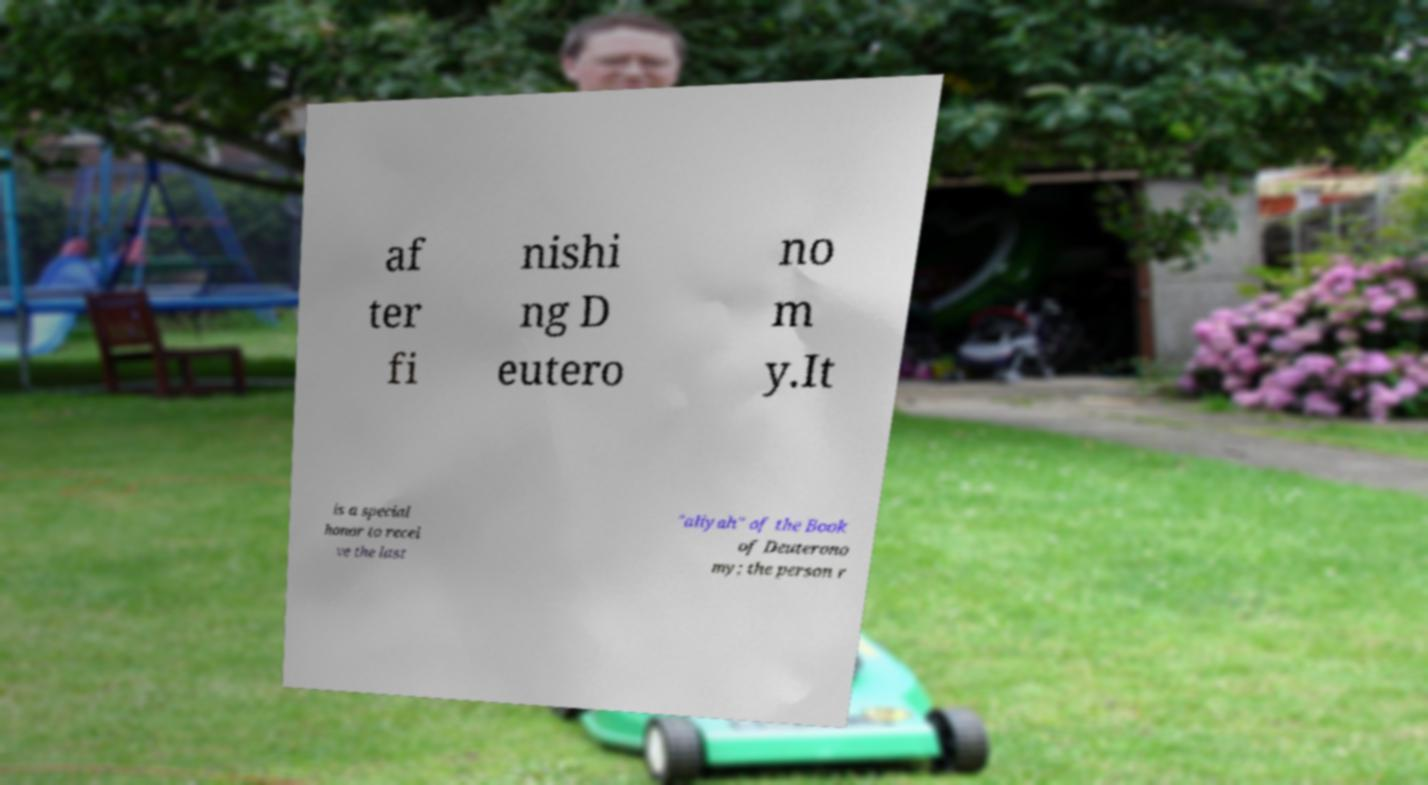I need the written content from this picture converted into text. Can you do that? af ter fi nishi ng D eutero no m y.It is a special honor to recei ve the last "aliyah" of the Book of Deuterono my; the person r 